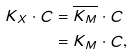<formula> <loc_0><loc_0><loc_500><loc_500>K _ { X } \cdot C & = \overline { K _ { M } } \cdot C \\ & = K _ { M } \cdot C ,</formula> 